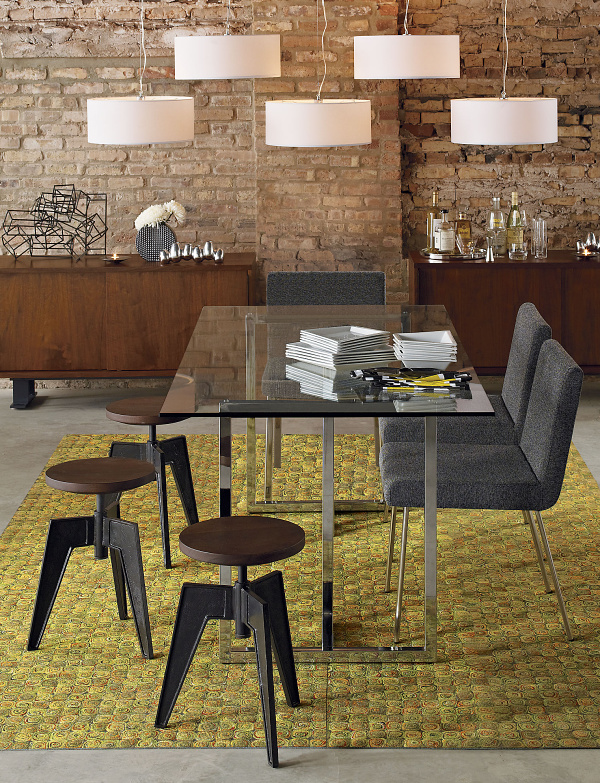Can you describe the setting and the mood of the room? Certainly! The room has a modern yet rustic charm, with a striking exposed brick wall as a backdrop. It evokes a warm and welcoming ambiance, enhanced by the soft glow from pendant lights with white shades. The selection of furniture, from the sleek dining set to the sideboard, all contribute to a cozy, stylish dining space ideal for both casual and formal gatherings. 